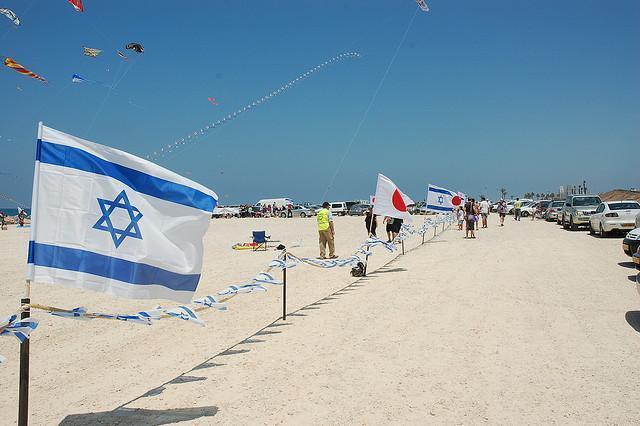How many flags are in the picture?
Give a very brief answer. 4. 